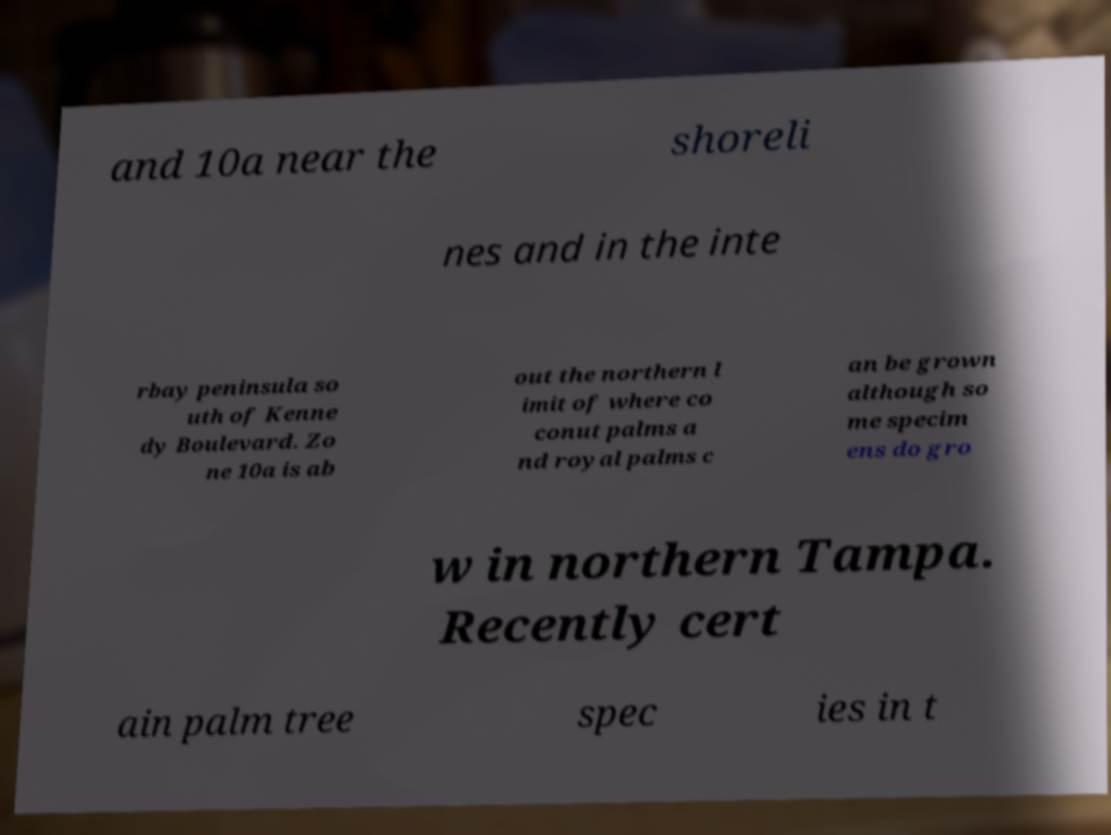Please read and relay the text visible in this image. What does it say? and 10a near the shoreli nes and in the inte rbay peninsula so uth of Kenne dy Boulevard. Zo ne 10a is ab out the northern l imit of where co conut palms a nd royal palms c an be grown although so me specim ens do gro w in northern Tampa. Recently cert ain palm tree spec ies in t 